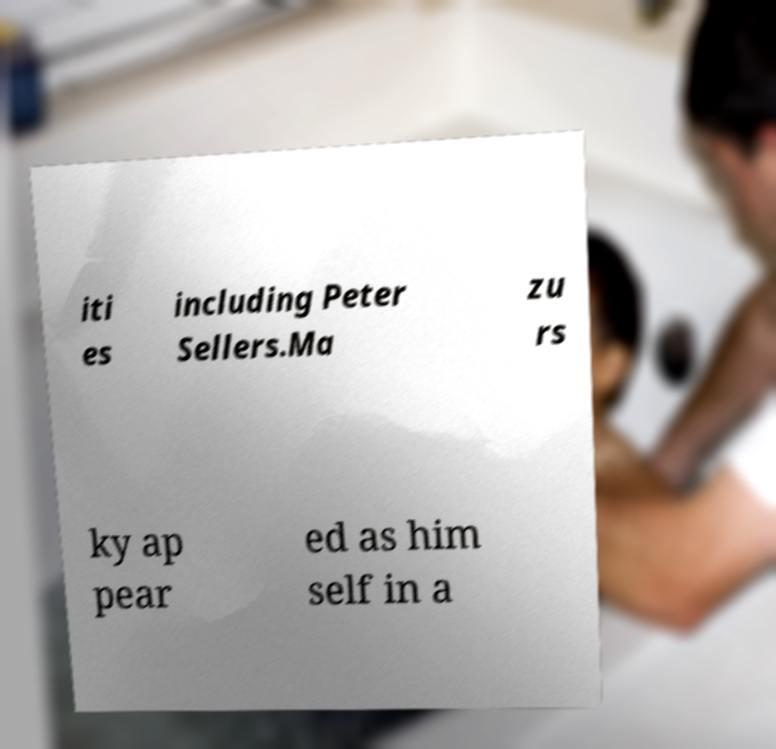Could you assist in decoding the text presented in this image and type it out clearly? iti es including Peter Sellers.Ma zu rs ky ap pear ed as him self in a 